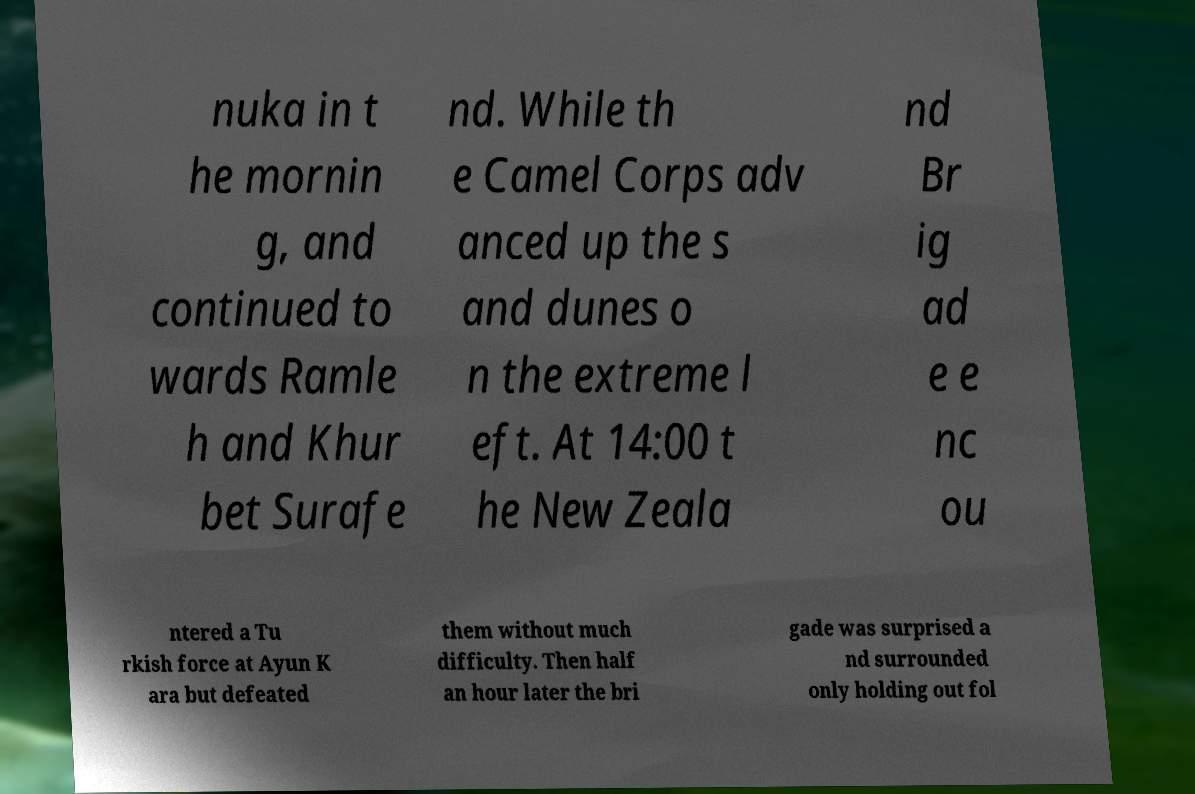Can you accurately transcribe the text from the provided image for me? nuka in t he mornin g, and continued to wards Ramle h and Khur bet Surafe nd. While th e Camel Corps adv anced up the s and dunes o n the extreme l eft. At 14:00 t he New Zeala nd Br ig ad e e nc ou ntered a Tu rkish force at Ayun K ara but defeated them without much difficulty. Then half an hour later the bri gade was surprised a nd surrounded only holding out fol 